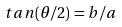Convert formula to latex. <formula><loc_0><loc_0><loc_500><loc_500>t a n ( \theta / 2 ) = b / a</formula> 